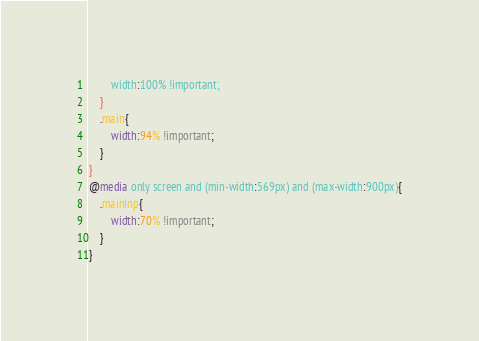<code> <loc_0><loc_0><loc_500><loc_500><_CSS_>        width:100% !important;
    }
    .main{
        width:94% !important;
    }
}
@media only screen and (min-width:569px) and (max-width:900px){
    .mainInp{
        width:70% !important;
    }
}
</code> 